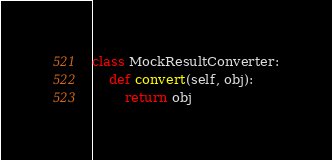Convert code to text. <code><loc_0><loc_0><loc_500><loc_500><_Python_>class MockResultConverter:
    def convert(self, obj):
        return obj</code> 